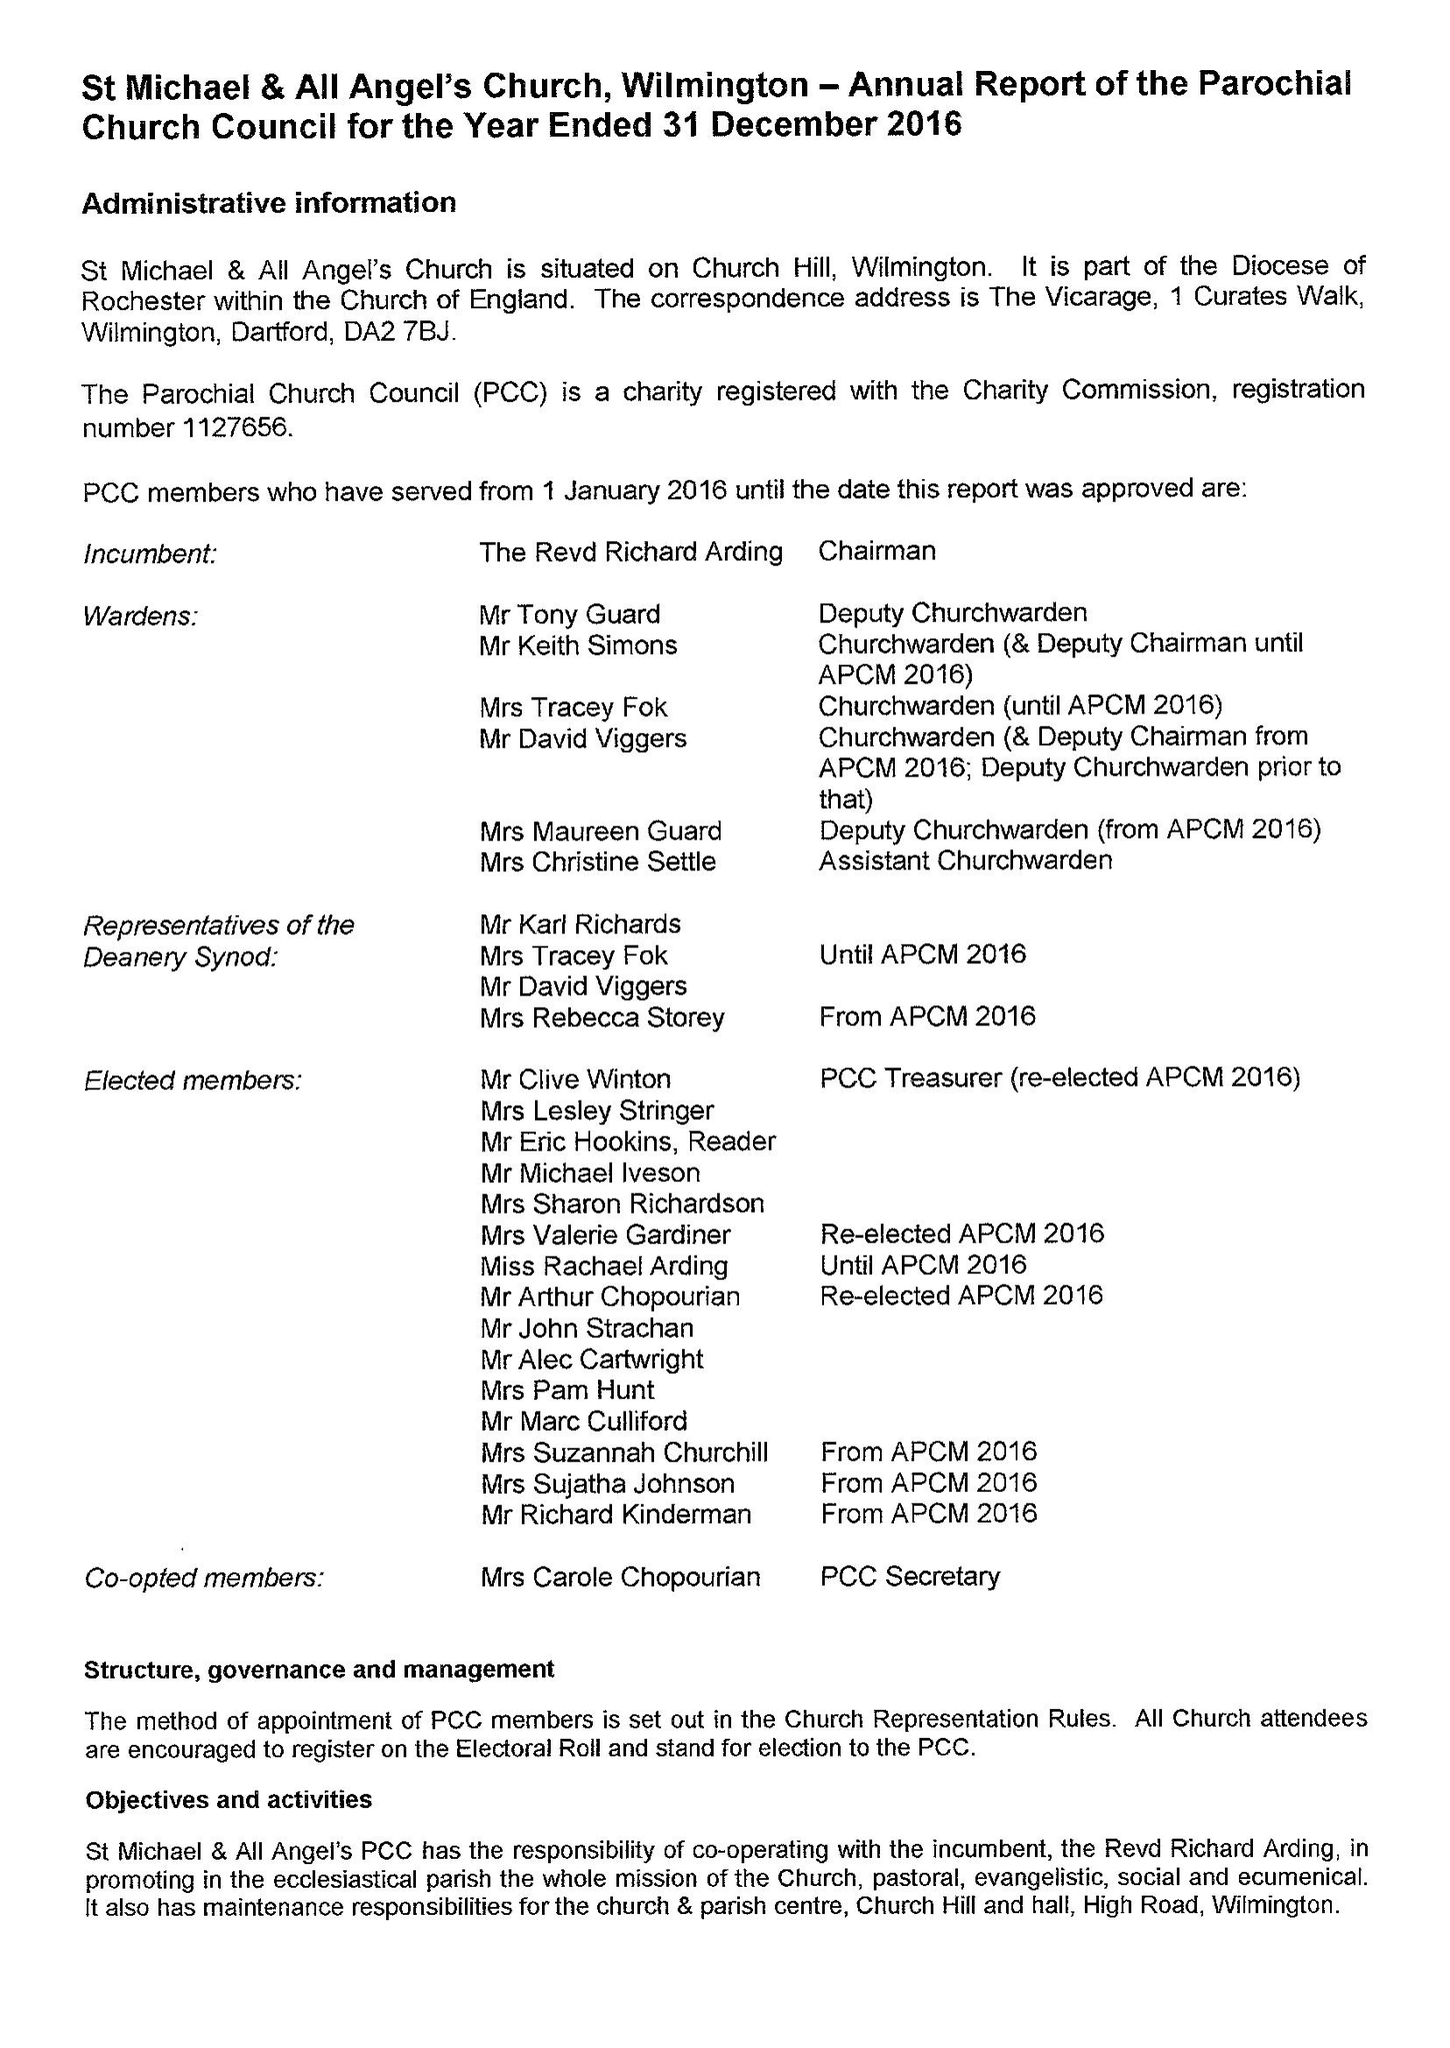What is the value for the charity_number?
Answer the question using a single word or phrase. 1127656 